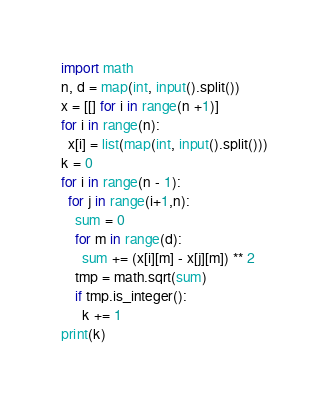<code> <loc_0><loc_0><loc_500><loc_500><_Python_>import math
n, d = map(int, input().split())
x = [[] for i in range(n +1)]
for i in range(n):
  x[i] = list(map(int, input().split()))
k = 0
for i in range(n - 1):
  for j in range(i+1,n):
    sum = 0
    for m in range(d):
      sum += (x[i][m] - x[j][m]) ** 2
    tmp = math.sqrt(sum)
    if tmp.is_integer():
      k += 1
print(k)  </code> 